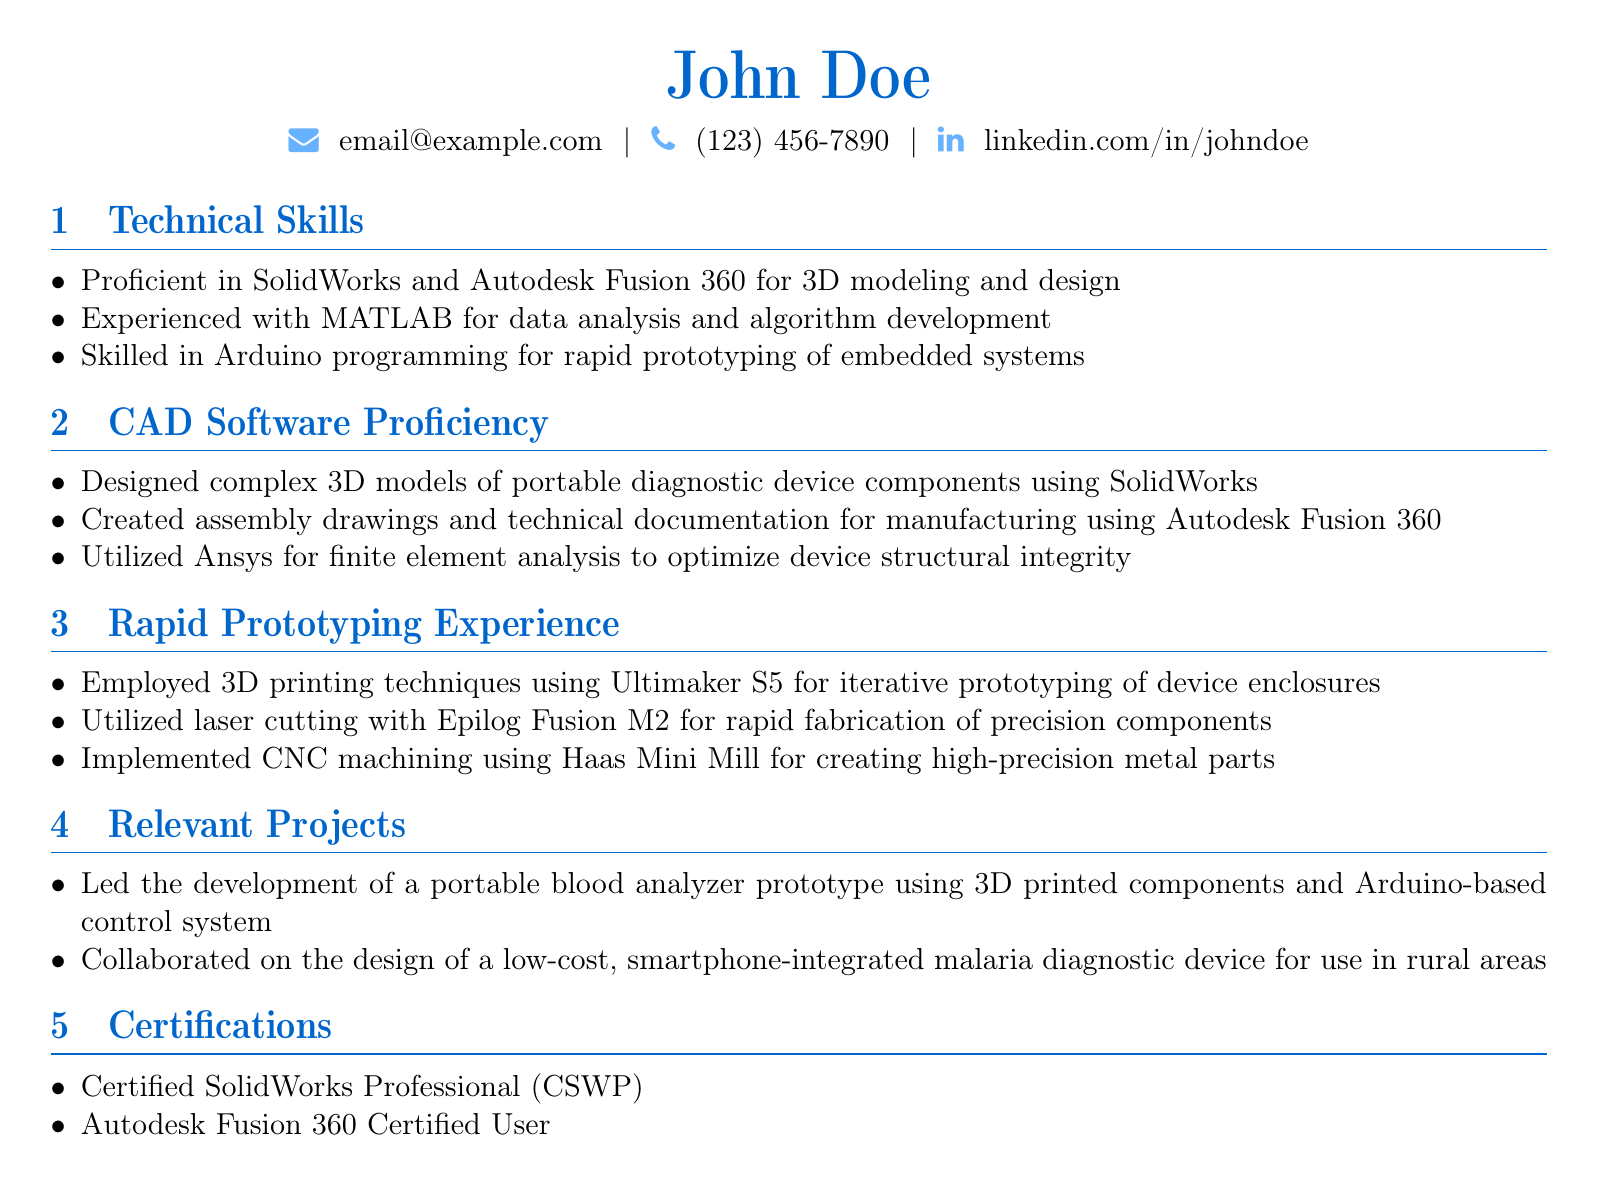what CAD software is mentioned for 3D modeling? The document lists SolidWorks and Autodesk Fusion 360 as the CAD software for 3D modeling.
Answer: SolidWorks and Autodesk Fusion 360 how many years of experience with MATLAB does the candidate have? The document does not specify the number of years of experience with MATLAB; it states they are experienced with it.
Answer: Not specified what technique is used for creating high-precision metal parts? The document states that CNC machining is used for creating high-precision metal parts.
Answer: CNC machining which certification specifies SolidWorks expertise? The document lists the Certified SolidWorks Professional (CSWP) as a certification that specifies expertise in SolidWorks.
Answer: Certified SolidWorks Professional (CSWP) how did the candidate prototype the portable blood analyzer? The document mentions the candidate used 3D printed components and an Arduino-based control system to prototype the device.
Answer: 3D printed components and Arduino-based control system which rapid prototyping tool is used for iterative prototyping? The document states that the Ultimaker S5 is used for iterative prototyping of device enclosures.
Answer: Ultimaker S5 what is the focus of the collaborated project on the malaria diagnostic device? The document indicates that the project focuses on designing a low-cost, smartphone-integrated device for use in rural areas.
Answer: Low-cost, smartphone-integrated device for rural areas who is the candidate? The document introduces the candidate as John Doe.
Answer: John Doe 